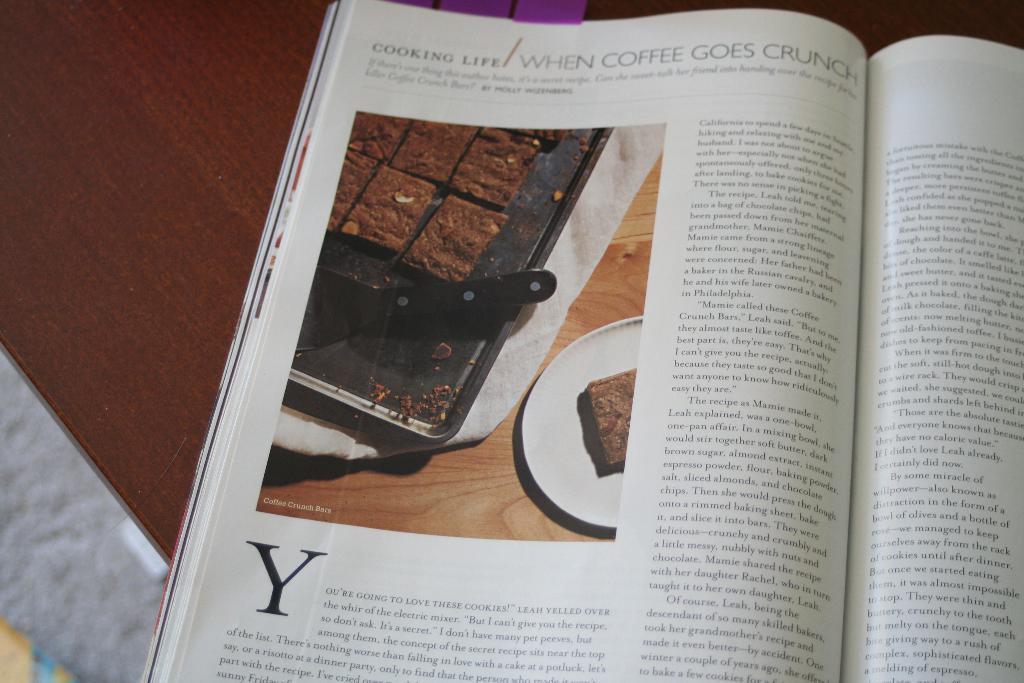What goes crunch in this recipe?
Give a very brief answer. Coffee. What kind of magazine is this?
Ensure brevity in your answer.  Cooking life. 